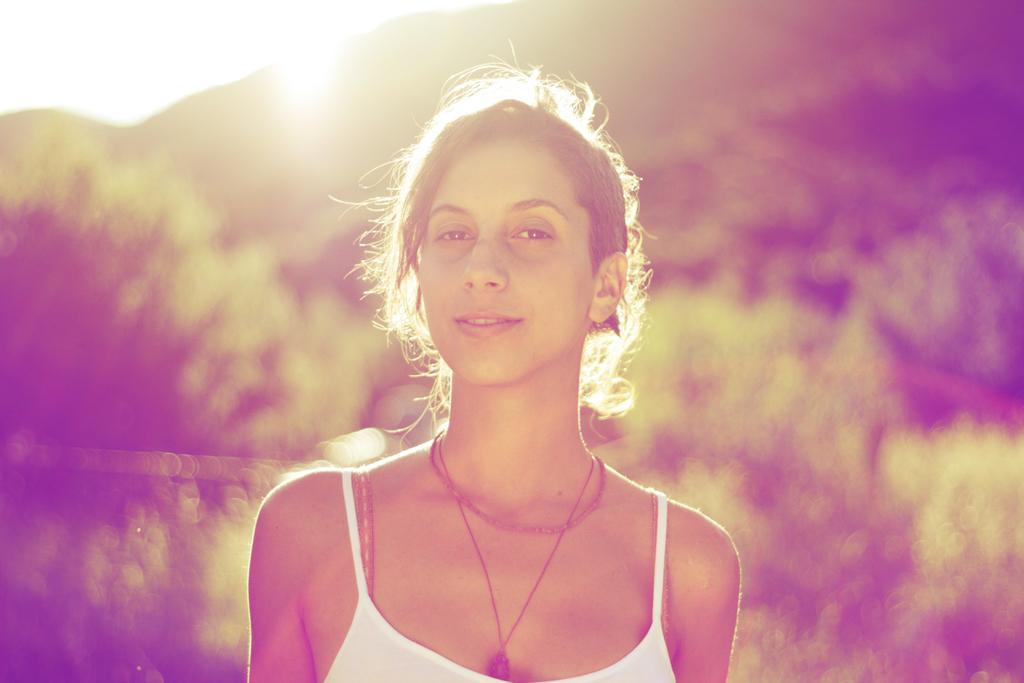Can you describe this image briefly? Front we can see a woman. Background it is blur. 